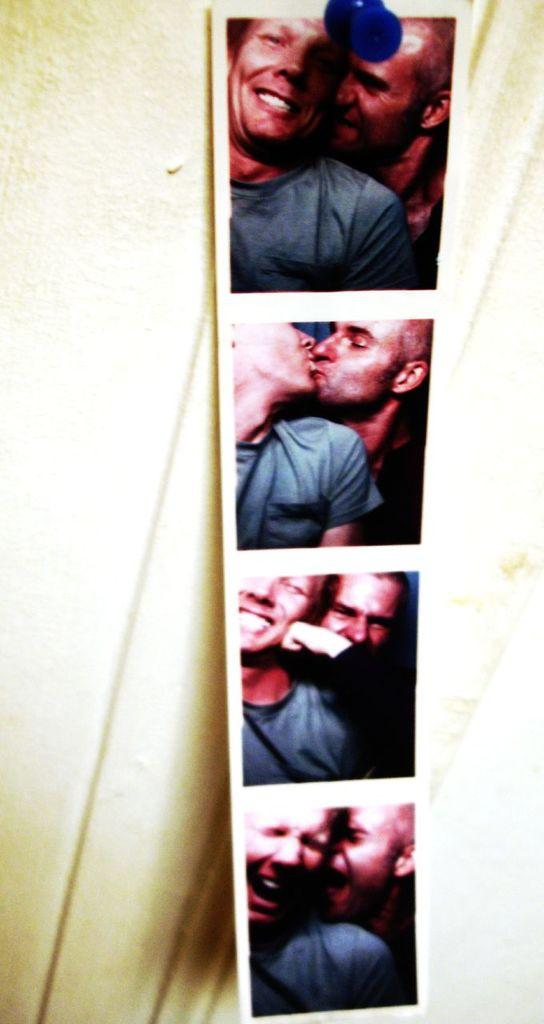What is displayed on the wall in the image? There is a photograph printed on the wall in the image. Can you describe the paper pin in the image? There is a paper pin at the top of the image. What type of mind control is being demonstrated in the image? There is no indication of mind control or any related activity in the image. Is eggnog being served in the image? There is no mention of eggnog or any food or drink in the image. 